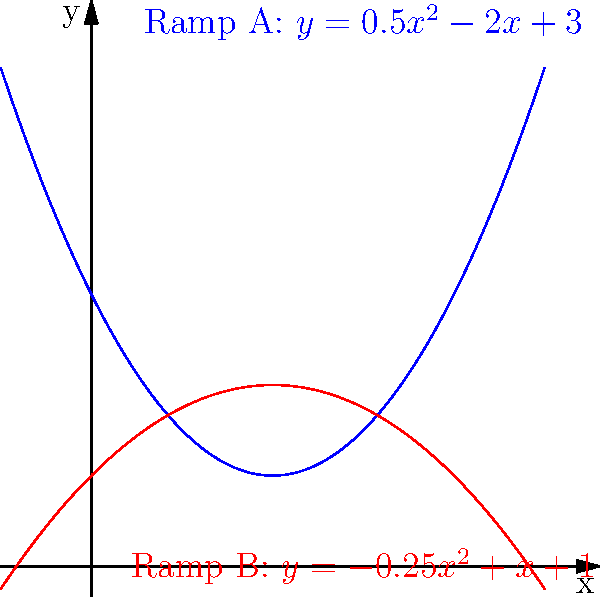You've been tasked with designing two ramps for a new skate park. The shapes of the ramps are modeled by the polynomial functions shown in the graph. At what x-coordinate do the two ramps intersect? Round your answer to two decimal places. To find the intersection point of the two ramps, we need to solve the equation:

$0.5x^2 - 2x + 3 = -0.25x^2 + x + 1$

Let's solve this step-by-step:

1) First, let's rearrange the equation so that all terms are on one side:
   $0.5x^2 - 2x + 3 + 0.25x^2 - x - 1 = 0$

2) Simplify by combining like terms:
   $0.75x^2 - 3x + 2 = 0$

3) This is a quadratic equation. We can solve it using the quadratic formula:
   $x = \frac{-b \pm \sqrt{b^2 - 4ac}}{2a}$

   Where $a = 0.75$, $b = -3$, and $c = 2$

4) Plugging these values into the quadratic formula:
   $x = \frac{3 \pm \sqrt{(-3)^2 - 4(0.75)(2)}}{2(0.75)}$

5) Simplify:
   $x = \frac{3 \pm \sqrt{9 - 6}}{1.5} = \frac{3 \pm \sqrt{3}}{1.5}$

6) This gives us two solutions:
   $x_1 = \frac{3 + \sqrt{3}}{1.5} \approx 2.37$
   $x_2 = \frac{3 - \sqrt{3}}{1.5} \approx 0.63$

7) Looking at the graph, we can see that the ramps intersect at the larger x-value.

Therefore, the x-coordinate of the intersection point, rounded to two decimal places, is 2.37.
Answer: 2.37 